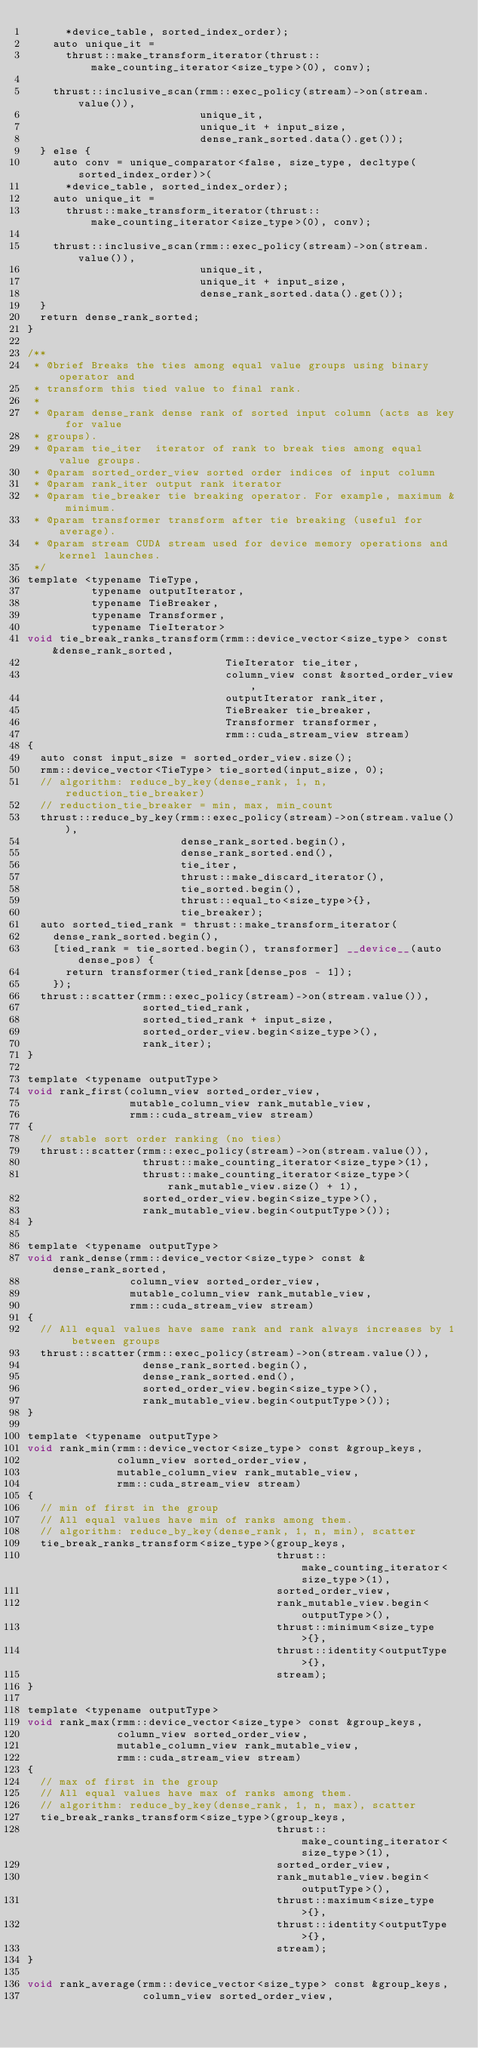<code> <loc_0><loc_0><loc_500><loc_500><_Cuda_>      *device_table, sorted_index_order);
    auto unique_it =
      thrust::make_transform_iterator(thrust::make_counting_iterator<size_type>(0), conv);

    thrust::inclusive_scan(rmm::exec_policy(stream)->on(stream.value()),
                           unique_it,
                           unique_it + input_size,
                           dense_rank_sorted.data().get());
  } else {
    auto conv = unique_comparator<false, size_type, decltype(sorted_index_order)>(
      *device_table, sorted_index_order);
    auto unique_it =
      thrust::make_transform_iterator(thrust::make_counting_iterator<size_type>(0), conv);

    thrust::inclusive_scan(rmm::exec_policy(stream)->on(stream.value()),
                           unique_it,
                           unique_it + input_size,
                           dense_rank_sorted.data().get());
  }
  return dense_rank_sorted;
}

/**
 * @brief Breaks the ties among equal value groups using binary operator and
 * transform this tied value to final rank.
 *
 * @param dense_rank dense rank of sorted input column (acts as key for value
 * groups).
 * @param tie_iter  iterator of rank to break ties among equal value groups.
 * @param sorted_order_view sorted order indices of input column
 * @param rank_iter output rank iterator
 * @param tie_breaker tie breaking operator. For example, maximum & minimum.
 * @param transformer transform after tie breaking (useful for average).
 * @param stream CUDA stream used for device memory operations and kernel launches.
 */
template <typename TieType,
          typename outputIterator,
          typename TieBreaker,
          typename Transformer,
          typename TieIterator>
void tie_break_ranks_transform(rmm::device_vector<size_type> const &dense_rank_sorted,
                               TieIterator tie_iter,
                               column_view const &sorted_order_view,
                               outputIterator rank_iter,
                               TieBreaker tie_breaker,
                               Transformer transformer,
                               rmm::cuda_stream_view stream)
{
  auto const input_size = sorted_order_view.size();
  rmm::device_vector<TieType> tie_sorted(input_size, 0);
  // algorithm: reduce_by_key(dense_rank, 1, n, reduction_tie_breaker)
  // reduction_tie_breaker = min, max, min_count
  thrust::reduce_by_key(rmm::exec_policy(stream)->on(stream.value()),
                        dense_rank_sorted.begin(),
                        dense_rank_sorted.end(),
                        tie_iter,
                        thrust::make_discard_iterator(),
                        tie_sorted.begin(),
                        thrust::equal_to<size_type>{},
                        tie_breaker);
  auto sorted_tied_rank = thrust::make_transform_iterator(
    dense_rank_sorted.begin(),
    [tied_rank = tie_sorted.begin(), transformer] __device__(auto dense_pos) {
      return transformer(tied_rank[dense_pos - 1]);
    });
  thrust::scatter(rmm::exec_policy(stream)->on(stream.value()),
                  sorted_tied_rank,
                  sorted_tied_rank + input_size,
                  sorted_order_view.begin<size_type>(),
                  rank_iter);
}

template <typename outputType>
void rank_first(column_view sorted_order_view,
                mutable_column_view rank_mutable_view,
                rmm::cuda_stream_view stream)
{
  // stable sort order ranking (no ties)
  thrust::scatter(rmm::exec_policy(stream)->on(stream.value()),
                  thrust::make_counting_iterator<size_type>(1),
                  thrust::make_counting_iterator<size_type>(rank_mutable_view.size() + 1),
                  sorted_order_view.begin<size_type>(),
                  rank_mutable_view.begin<outputType>());
}

template <typename outputType>
void rank_dense(rmm::device_vector<size_type> const &dense_rank_sorted,
                column_view sorted_order_view,
                mutable_column_view rank_mutable_view,
                rmm::cuda_stream_view stream)
{
  // All equal values have same rank and rank always increases by 1 between groups
  thrust::scatter(rmm::exec_policy(stream)->on(stream.value()),
                  dense_rank_sorted.begin(),
                  dense_rank_sorted.end(),
                  sorted_order_view.begin<size_type>(),
                  rank_mutable_view.begin<outputType>());
}

template <typename outputType>
void rank_min(rmm::device_vector<size_type> const &group_keys,
              column_view sorted_order_view,
              mutable_column_view rank_mutable_view,
              rmm::cuda_stream_view stream)
{
  // min of first in the group
  // All equal values have min of ranks among them.
  // algorithm: reduce_by_key(dense_rank, 1, n, min), scatter
  tie_break_ranks_transform<size_type>(group_keys,
                                       thrust::make_counting_iterator<size_type>(1),
                                       sorted_order_view,
                                       rank_mutable_view.begin<outputType>(),
                                       thrust::minimum<size_type>{},
                                       thrust::identity<outputType>{},
                                       stream);
}

template <typename outputType>
void rank_max(rmm::device_vector<size_type> const &group_keys,
              column_view sorted_order_view,
              mutable_column_view rank_mutable_view,
              rmm::cuda_stream_view stream)
{
  // max of first in the group
  // All equal values have max of ranks among them.
  // algorithm: reduce_by_key(dense_rank, 1, n, max), scatter
  tie_break_ranks_transform<size_type>(group_keys,
                                       thrust::make_counting_iterator<size_type>(1),
                                       sorted_order_view,
                                       rank_mutable_view.begin<outputType>(),
                                       thrust::maximum<size_type>{},
                                       thrust::identity<outputType>{},
                                       stream);
}

void rank_average(rmm::device_vector<size_type> const &group_keys,
                  column_view sorted_order_view,</code> 